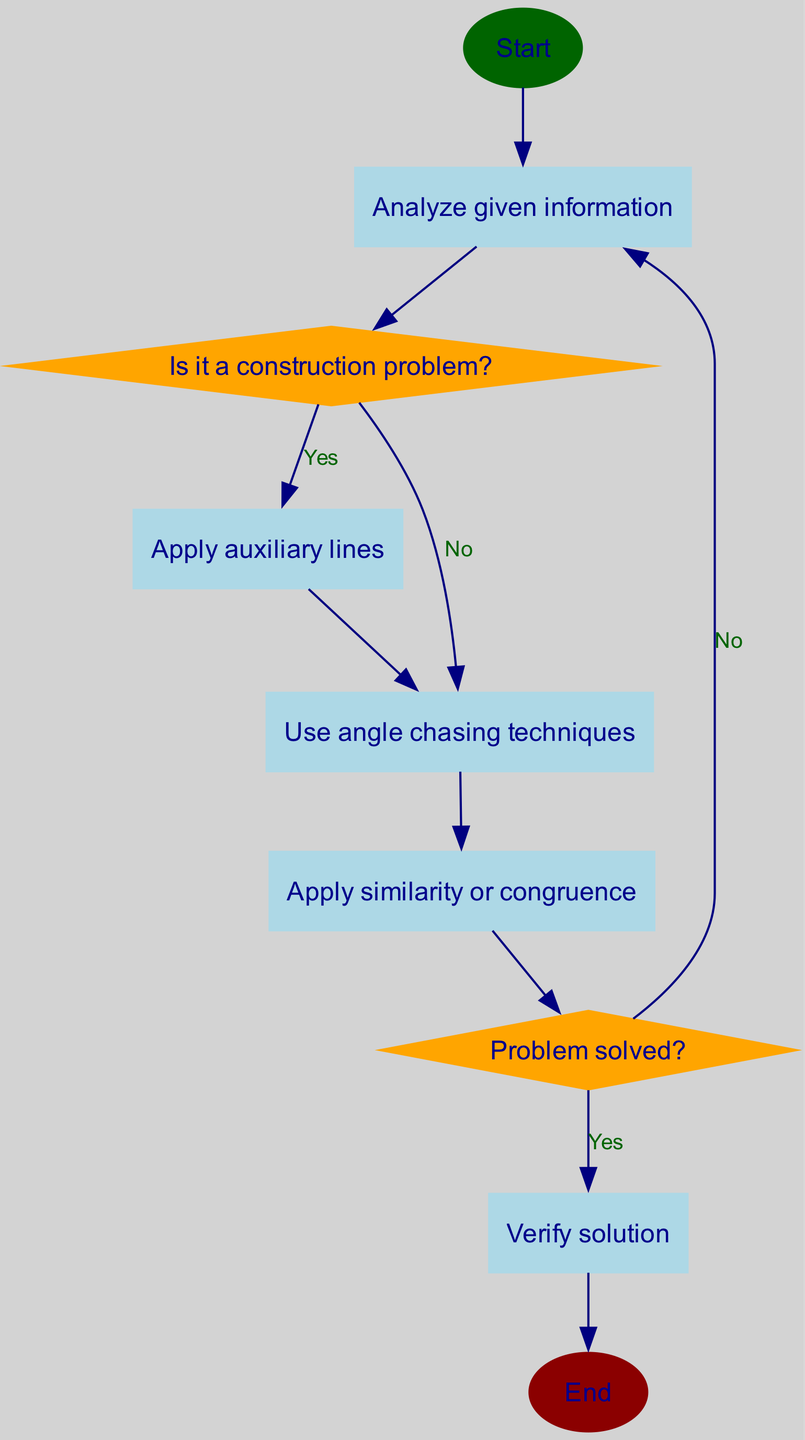What is the first step in the algorithm? The diagram indicates that the first step is "Start," which leads to the next action of analyzing given information.
Answer: Start How many decision points are present in the diagram? Upon examining the diagram, there are two decision points: "Is it a construction problem?" and "Problem solved?"
Answer: 2 What action follows "Analyze given information"? The flow shows that after "Analyze given information," the next action is transitioning to the decision "Is it a construction problem?"
Answer: Is it a construction problem? If the answer to "Is it a construction problem?" is "No," what is the next action? In this case, according to the diagram, answering "No" leads directly to the action "Use angle chasing techniques."
Answer: Use angle chasing techniques After "Apply similarity or congruence," what question must be answered next? The sequence clearly indicates that after completing "Apply similarity or congruence," the next logical step is to ask, "Problem solved?"
Answer: Problem solved? If "Problem solved?" is answered with "No," which action is taken? Following that response, the flow returns to reanalyzing the given information, as indicated in the diagram.
Answer: Analyze given information What is the final step in the algorithm? According to the end of the flowchart, the last step, following a verified solution, is "End."
Answer: End Which processes are applied after confirming it is not a construction problem? After confirming it is not a construction problem, the flow diagram indicates that two processes occur: "Use angle chasing techniques" followed by "Apply similarity or congruence."
Answer: Use angle chasing techniques, Apply similarity or congruence What color is used for decision nodes in the diagram? The diagram specifies that decision nodes are indicated by the color orange, distinguishing them from process nodes.
Answer: Orange 